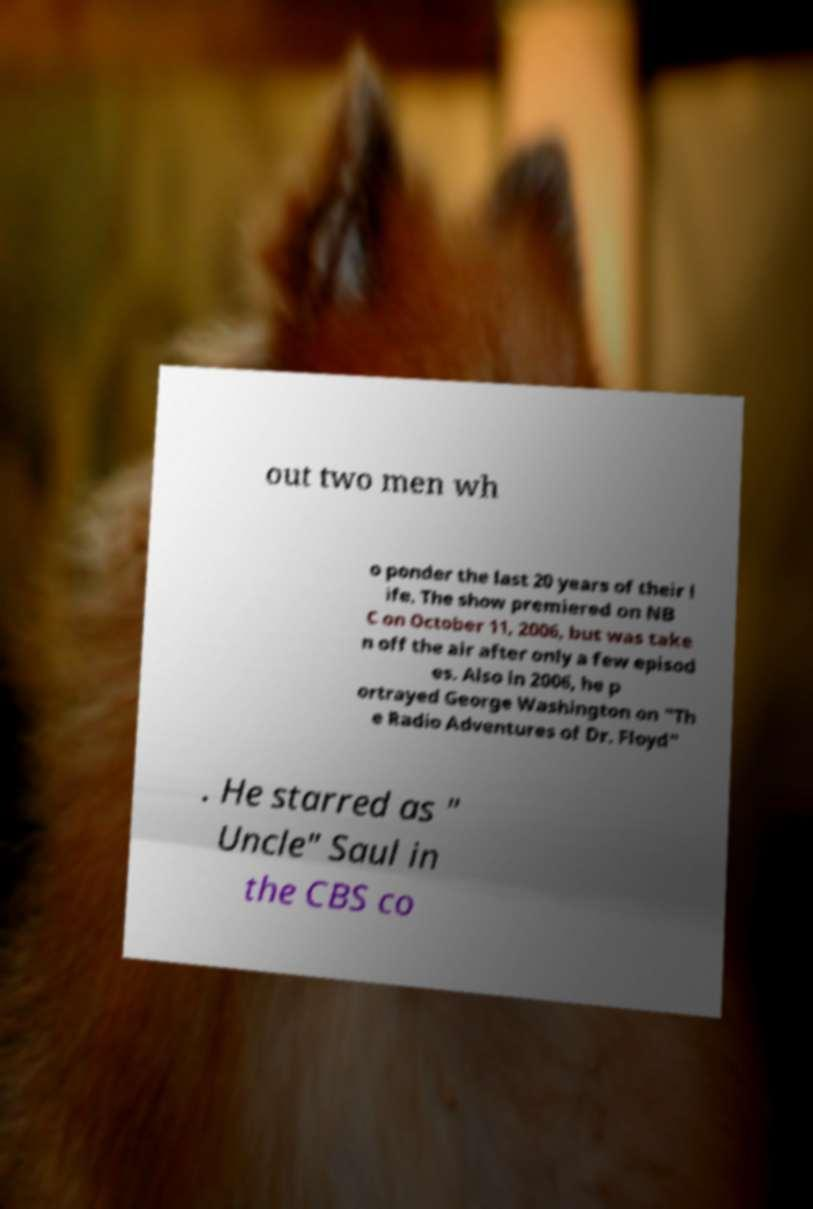Please identify and transcribe the text found in this image. out two men wh o ponder the last 20 years of their l ife. The show premiered on NB C on October 11, 2006, but was take n off the air after only a few episod es. Also in 2006, he p ortrayed George Washington on "Th e Radio Adventures of Dr. Floyd" . He starred as " Uncle" Saul in the CBS co 